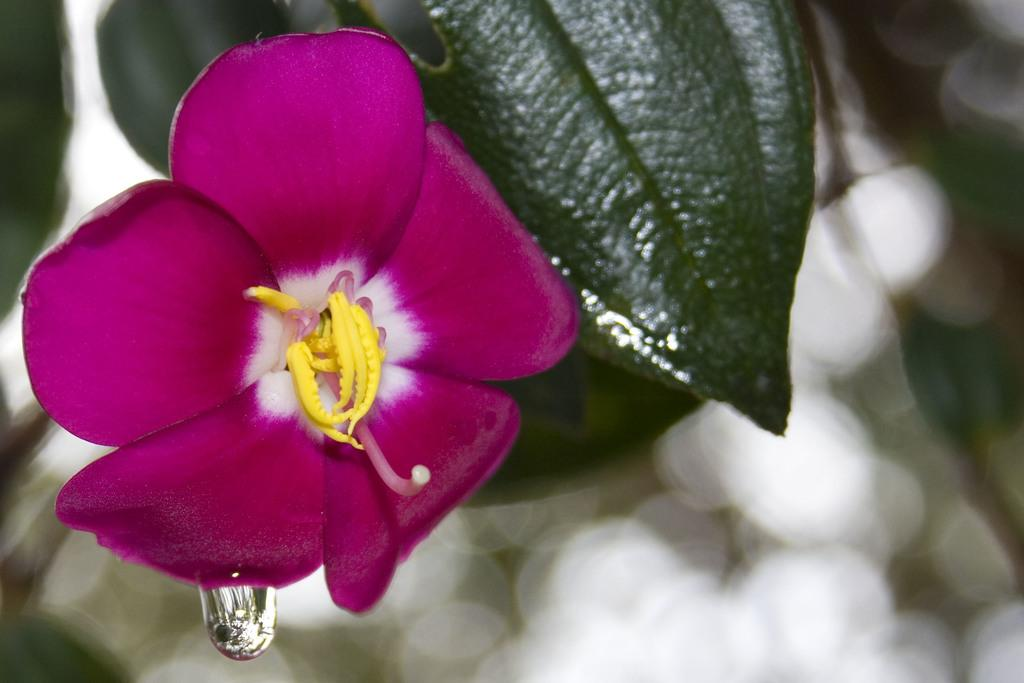What is the main subject of the image? There is a flower in the image. What else can be seen in the image besides the flower? There are leaves and a water droplet in the image. Can you describe the background of the image? The background of the image is not clear. What type of card is being used to hold the flower in the image? There is no card present in the image; the flower is not being held by any card. 